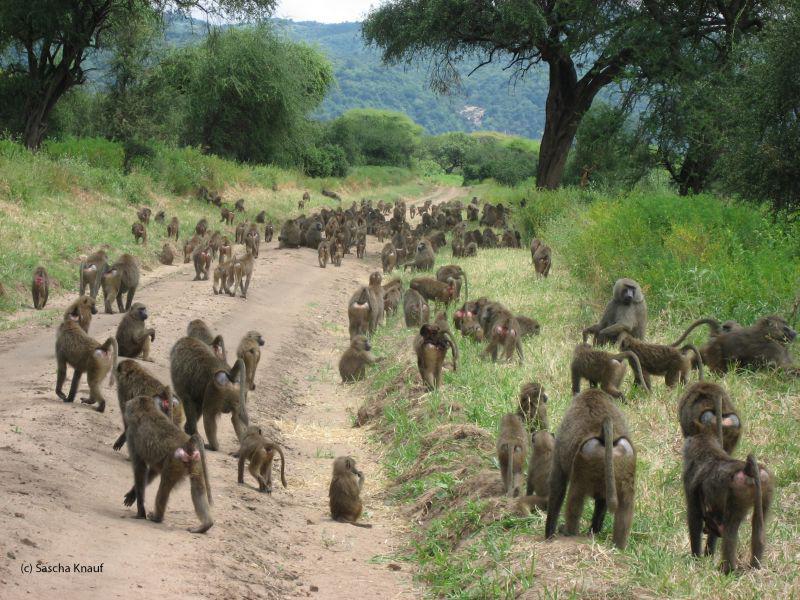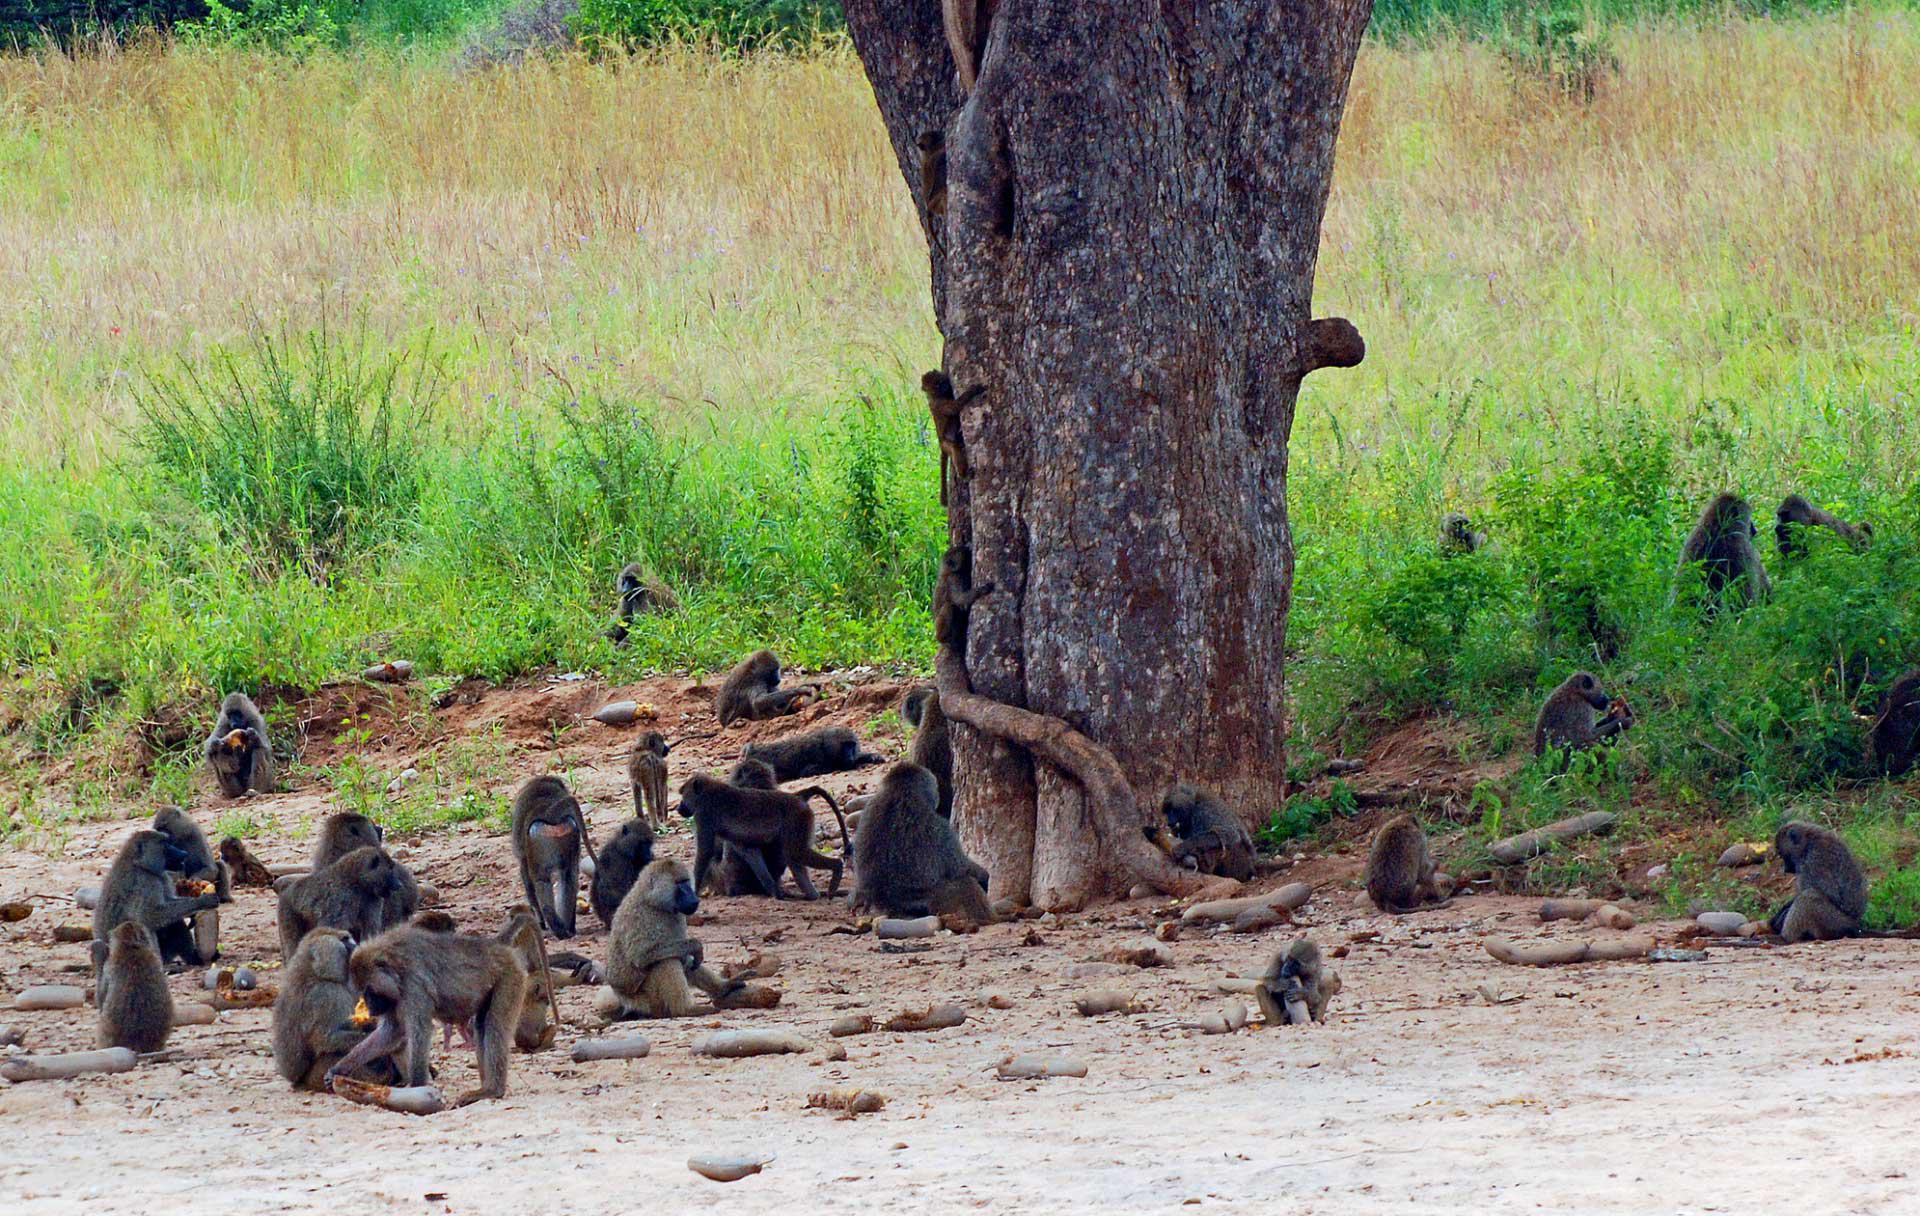The first image is the image on the left, the second image is the image on the right. Evaluate the accuracy of this statement regarding the images: "An image shows baboons sitting in a patch of dirt near a tree.". Is it true? Answer yes or no. Yes. The first image is the image on the left, the second image is the image on the right. For the images displayed, is the sentence "Some of the animals are in a dirt path." factually correct? Answer yes or no. Yes. 